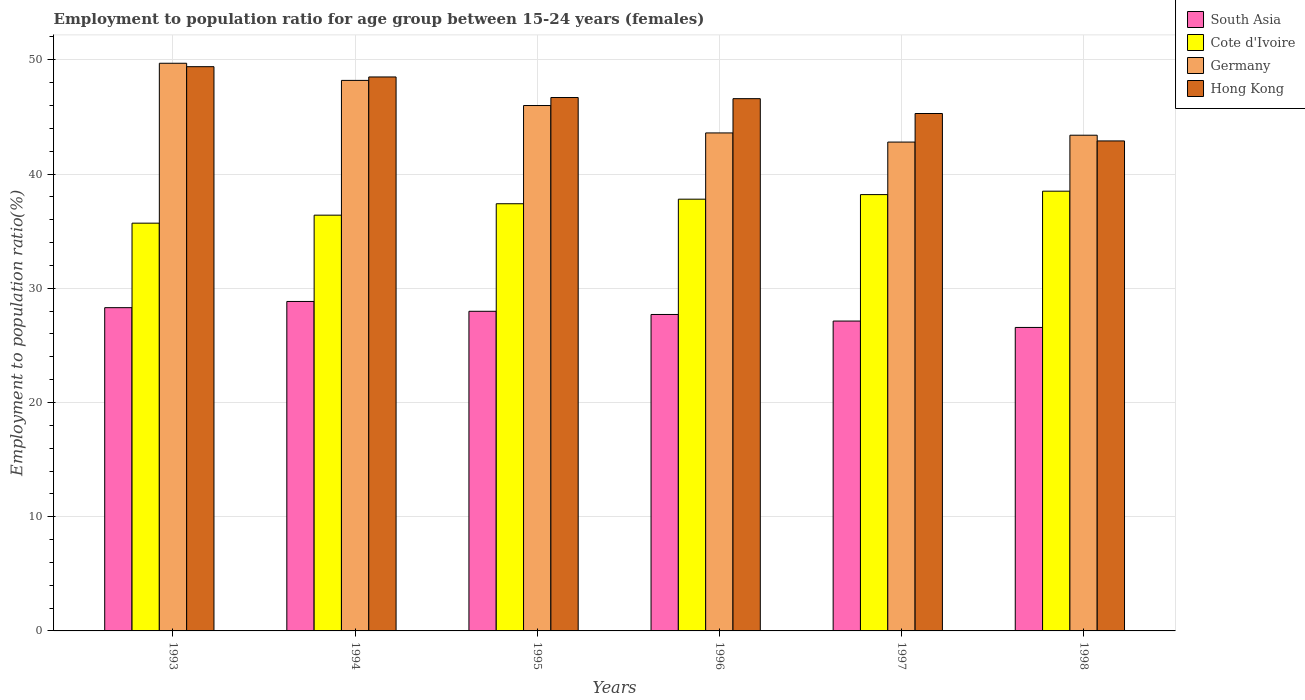Are the number of bars per tick equal to the number of legend labels?
Offer a very short reply. Yes. Are the number of bars on each tick of the X-axis equal?
Make the answer very short. Yes. How many bars are there on the 3rd tick from the left?
Ensure brevity in your answer.  4. How many bars are there on the 5th tick from the right?
Keep it short and to the point. 4. What is the employment to population ratio in Hong Kong in 1993?
Your answer should be very brief. 49.4. Across all years, what is the maximum employment to population ratio in South Asia?
Give a very brief answer. 28.85. Across all years, what is the minimum employment to population ratio in Germany?
Your answer should be compact. 42.8. In which year was the employment to population ratio in South Asia minimum?
Offer a very short reply. 1998. What is the total employment to population ratio in Cote d'Ivoire in the graph?
Offer a very short reply. 224. What is the difference between the employment to population ratio in Cote d'Ivoire in 1997 and the employment to population ratio in Hong Kong in 1998?
Make the answer very short. -4.7. What is the average employment to population ratio in Hong Kong per year?
Give a very brief answer. 46.57. In the year 1994, what is the difference between the employment to population ratio in Cote d'Ivoire and employment to population ratio in Germany?
Give a very brief answer. -11.8. In how many years, is the employment to population ratio in Hong Kong greater than 18 %?
Your answer should be very brief. 6. What is the ratio of the employment to population ratio in South Asia in 1993 to that in 1998?
Offer a very short reply. 1.07. What is the difference between the highest and the second highest employment to population ratio in Hong Kong?
Provide a short and direct response. 0.9. What is the difference between the highest and the lowest employment to population ratio in South Asia?
Keep it short and to the point. 2.27. What does the 2nd bar from the left in 1994 represents?
Keep it short and to the point. Cote d'Ivoire. Is it the case that in every year, the sum of the employment to population ratio in Hong Kong and employment to population ratio in Germany is greater than the employment to population ratio in Cote d'Ivoire?
Offer a terse response. Yes. How many bars are there?
Your response must be concise. 24. Are all the bars in the graph horizontal?
Provide a succinct answer. No. What is the difference between two consecutive major ticks on the Y-axis?
Your answer should be very brief. 10. Are the values on the major ticks of Y-axis written in scientific E-notation?
Provide a short and direct response. No. Does the graph contain grids?
Your answer should be compact. Yes. What is the title of the graph?
Provide a succinct answer. Employment to population ratio for age group between 15-24 years (females). Does "Tajikistan" appear as one of the legend labels in the graph?
Provide a succinct answer. No. What is the label or title of the X-axis?
Your answer should be compact. Years. What is the label or title of the Y-axis?
Give a very brief answer. Employment to population ratio(%). What is the Employment to population ratio(%) of South Asia in 1993?
Your answer should be compact. 28.3. What is the Employment to population ratio(%) in Cote d'Ivoire in 1993?
Provide a succinct answer. 35.7. What is the Employment to population ratio(%) of Germany in 1993?
Ensure brevity in your answer.  49.7. What is the Employment to population ratio(%) of Hong Kong in 1993?
Your response must be concise. 49.4. What is the Employment to population ratio(%) of South Asia in 1994?
Your response must be concise. 28.85. What is the Employment to population ratio(%) of Cote d'Ivoire in 1994?
Provide a succinct answer. 36.4. What is the Employment to population ratio(%) in Germany in 1994?
Keep it short and to the point. 48.2. What is the Employment to population ratio(%) in Hong Kong in 1994?
Provide a short and direct response. 48.5. What is the Employment to population ratio(%) of South Asia in 1995?
Keep it short and to the point. 27.98. What is the Employment to population ratio(%) in Cote d'Ivoire in 1995?
Your answer should be compact. 37.4. What is the Employment to population ratio(%) in Hong Kong in 1995?
Ensure brevity in your answer.  46.7. What is the Employment to population ratio(%) of South Asia in 1996?
Give a very brief answer. 27.7. What is the Employment to population ratio(%) of Cote d'Ivoire in 1996?
Provide a succinct answer. 37.8. What is the Employment to population ratio(%) in Germany in 1996?
Give a very brief answer. 43.6. What is the Employment to population ratio(%) of Hong Kong in 1996?
Your answer should be compact. 46.6. What is the Employment to population ratio(%) of South Asia in 1997?
Ensure brevity in your answer.  27.13. What is the Employment to population ratio(%) of Cote d'Ivoire in 1997?
Make the answer very short. 38.2. What is the Employment to population ratio(%) of Germany in 1997?
Provide a short and direct response. 42.8. What is the Employment to population ratio(%) in Hong Kong in 1997?
Ensure brevity in your answer.  45.3. What is the Employment to population ratio(%) in South Asia in 1998?
Keep it short and to the point. 26.57. What is the Employment to population ratio(%) in Cote d'Ivoire in 1998?
Offer a very short reply. 38.5. What is the Employment to population ratio(%) in Germany in 1998?
Provide a short and direct response. 43.4. What is the Employment to population ratio(%) in Hong Kong in 1998?
Your answer should be very brief. 42.9. Across all years, what is the maximum Employment to population ratio(%) in South Asia?
Offer a very short reply. 28.85. Across all years, what is the maximum Employment to population ratio(%) in Cote d'Ivoire?
Provide a short and direct response. 38.5. Across all years, what is the maximum Employment to population ratio(%) of Germany?
Your response must be concise. 49.7. Across all years, what is the maximum Employment to population ratio(%) of Hong Kong?
Provide a short and direct response. 49.4. Across all years, what is the minimum Employment to population ratio(%) of South Asia?
Offer a very short reply. 26.57. Across all years, what is the minimum Employment to population ratio(%) of Cote d'Ivoire?
Provide a short and direct response. 35.7. Across all years, what is the minimum Employment to population ratio(%) of Germany?
Provide a succinct answer. 42.8. Across all years, what is the minimum Employment to population ratio(%) in Hong Kong?
Your answer should be very brief. 42.9. What is the total Employment to population ratio(%) in South Asia in the graph?
Offer a terse response. 166.54. What is the total Employment to population ratio(%) in Cote d'Ivoire in the graph?
Your response must be concise. 224. What is the total Employment to population ratio(%) in Germany in the graph?
Your answer should be very brief. 273.7. What is the total Employment to population ratio(%) of Hong Kong in the graph?
Your response must be concise. 279.4. What is the difference between the Employment to population ratio(%) in South Asia in 1993 and that in 1994?
Provide a short and direct response. -0.54. What is the difference between the Employment to population ratio(%) of Cote d'Ivoire in 1993 and that in 1994?
Your answer should be very brief. -0.7. What is the difference between the Employment to population ratio(%) of Germany in 1993 and that in 1994?
Provide a short and direct response. 1.5. What is the difference between the Employment to population ratio(%) of Hong Kong in 1993 and that in 1994?
Provide a succinct answer. 0.9. What is the difference between the Employment to population ratio(%) of South Asia in 1993 and that in 1995?
Your answer should be very brief. 0.32. What is the difference between the Employment to population ratio(%) of Cote d'Ivoire in 1993 and that in 1995?
Your answer should be compact. -1.7. What is the difference between the Employment to population ratio(%) of Germany in 1993 and that in 1995?
Your answer should be very brief. 3.7. What is the difference between the Employment to population ratio(%) in Hong Kong in 1993 and that in 1995?
Your response must be concise. 2.7. What is the difference between the Employment to population ratio(%) in South Asia in 1993 and that in 1996?
Offer a very short reply. 0.6. What is the difference between the Employment to population ratio(%) of Cote d'Ivoire in 1993 and that in 1996?
Your answer should be compact. -2.1. What is the difference between the Employment to population ratio(%) in Germany in 1993 and that in 1996?
Your answer should be very brief. 6.1. What is the difference between the Employment to population ratio(%) in South Asia in 1993 and that in 1997?
Your response must be concise. 1.17. What is the difference between the Employment to population ratio(%) in Hong Kong in 1993 and that in 1997?
Provide a succinct answer. 4.1. What is the difference between the Employment to population ratio(%) in South Asia in 1993 and that in 1998?
Keep it short and to the point. 1.73. What is the difference between the Employment to population ratio(%) of Hong Kong in 1993 and that in 1998?
Offer a very short reply. 6.5. What is the difference between the Employment to population ratio(%) in South Asia in 1994 and that in 1995?
Offer a very short reply. 0.86. What is the difference between the Employment to population ratio(%) of South Asia in 1994 and that in 1996?
Give a very brief answer. 1.14. What is the difference between the Employment to population ratio(%) of Cote d'Ivoire in 1994 and that in 1996?
Offer a very short reply. -1.4. What is the difference between the Employment to population ratio(%) of Hong Kong in 1994 and that in 1996?
Provide a short and direct response. 1.9. What is the difference between the Employment to population ratio(%) of South Asia in 1994 and that in 1997?
Give a very brief answer. 1.72. What is the difference between the Employment to population ratio(%) of Germany in 1994 and that in 1997?
Keep it short and to the point. 5.4. What is the difference between the Employment to population ratio(%) of South Asia in 1994 and that in 1998?
Provide a short and direct response. 2.27. What is the difference between the Employment to population ratio(%) in Cote d'Ivoire in 1994 and that in 1998?
Make the answer very short. -2.1. What is the difference between the Employment to population ratio(%) of Hong Kong in 1994 and that in 1998?
Offer a terse response. 5.6. What is the difference between the Employment to population ratio(%) of South Asia in 1995 and that in 1996?
Offer a terse response. 0.28. What is the difference between the Employment to population ratio(%) of Cote d'Ivoire in 1995 and that in 1996?
Offer a very short reply. -0.4. What is the difference between the Employment to population ratio(%) in South Asia in 1995 and that in 1997?
Keep it short and to the point. 0.86. What is the difference between the Employment to population ratio(%) of Cote d'Ivoire in 1995 and that in 1997?
Make the answer very short. -0.8. What is the difference between the Employment to population ratio(%) of South Asia in 1995 and that in 1998?
Make the answer very short. 1.41. What is the difference between the Employment to population ratio(%) of Cote d'Ivoire in 1995 and that in 1998?
Offer a very short reply. -1.1. What is the difference between the Employment to population ratio(%) in South Asia in 1996 and that in 1997?
Give a very brief answer. 0.58. What is the difference between the Employment to population ratio(%) of Cote d'Ivoire in 1996 and that in 1997?
Give a very brief answer. -0.4. What is the difference between the Employment to population ratio(%) in Hong Kong in 1996 and that in 1997?
Give a very brief answer. 1.3. What is the difference between the Employment to population ratio(%) of South Asia in 1996 and that in 1998?
Your answer should be very brief. 1.13. What is the difference between the Employment to population ratio(%) of Cote d'Ivoire in 1996 and that in 1998?
Your answer should be compact. -0.7. What is the difference between the Employment to population ratio(%) of Hong Kong in 1996 and that in 1998?
Your answer should be very brief. 3.7. What is the difference between the Employment to population ratio(%) in South Asia in 1997 and that in 1998?
Offer a terse response. 0.56. What is the difference between the Employment to population ratio(%) of South Asia in 1993 and the Employment to population ratio(%) of Cote d'Ivoire in 1994?
Give a very brief answer. -8.1. What is the difference between the Employment to population ratio(%) in South Asia in 1993 and the Employment to population ratio(%) in Germany in 1994?
Ensure brevity in your answer.  -19.9. What is the difference between the Employment to population ratio(%) of South Asia in 1993 and the Employment to population ratio(%) of Hong Kong in 1994?
Make the answer very short. -20.2. What is the difference between the Employment to population ratio(%) of Cote d'Ivoire in 1993 and the Employment to population ratio(%) of Germany in 1994?
Your response must be concise. -12.5. What is the difference between the Employment to population ratio(%) in Germany in 1993 and the Employment to population ratio(%) in Hong Kong in 1994?
Give a very brief answer. 1.2. What is the difference between the Employment to population ratio(%) of South Asia in 1993 and the Employment to population ratio(%) of Cote d'Ivoire in 1995?
Make the answer very short. -9.1. What is the difference between the Employment to population ratio(%) of South Asia in 1993 and the Employment to population ratio(%) of Germany in 1995?
Provide a short and direct response. -17.7. What is the difference between the Employment to population ratio(%) of South Asia in 1993 and the Employment to population ratio(%) of Hong Kong in 1995?
Provide a succinct answer. -18.4. What is the difference between the Employment to population ratio(%) of Cote d'Ivoire in 1993 and the Employment to population ratio(%) of Germany in 1995?
Your answer should be compact. -10.3. What is the difference between the Employment to population ratio(%) of Cote d'Ivoire in 1993 and the Employment to population ratio(%) of Hong Kong in 1995?
Make the answer very short. -11. What is the difference between the Employment to population ratio(%) of Germany in 1993 and the Employment to population ratio(%) of Hong Kong in 1995?
Your response must be concise. 3. What is the difference between the Employment to population ratio(%) in South Asia in 1993 and the Employment to population ratio(%) in Cote d'Ivoire in 1996?
Give a very brief answer. -9.5. What is the difference between the Employment to population ratio(%) of South Asia in 1993 and the Employment to population ratio(%) of Germany in 1996?
Your answer should be compact. -15.3. What is the difference between the Employment to population ratio(%) of South Asia in 1993 and the Employment to population ratio(%) of Hong Kong in 1996?
Provide a short and direct response. -18.3. What is the difference between the Employment to population ratio(%) of Cote d'Ivoire in 1993 and the Employment to population ratio(%) of Germany in 1996?
Offer a very short reply. -7.9. What is the difference between the Employment to population ratio(%) in Cote d'Ivoire in 1993 and the Employment to population ratio(%) in Hong Kong in 1996?
Provide a succinct answer. -10.9. What is the difference between the Employment to population ratio(%) of South Asia in 1993 and the Employment to population ratio(%) of Cote d'Ivoire in 1997?
Make the answer very short. -9.9. What is the difference between the Employment to population ratio(%) of South Asia in 1993 and the Employment to population ratio(%) of Germany in 1997?
Your answer should be compact. -14.5. What is the difference between the Employment to population ratio(%) of South Asia in 1993 and the Employment to population ratio(%) of Hong Kong in 1997?
Offer a very short reply. -17. What is the difference between the Employment to population ratio(%) of Cote d'Ivoire in 1993 and the Employment to population ratio(%) of Germany in 1997?
Make the answer very short. -7.1. What is the difference between the Employment to population ratio(%) in Germany in 1993 and the Employment to population ratio(%) in Hong Kong in 1997?
Your answer should be very brief. 4.4. What is the difference between the Employment to population ratio(%) of South Asia in 1993 and the Employment to population ratio(%) of Cote d'Ivoire in 1998?
Your response must be concise. -10.2. What is the difference between the Employment to population ratio(%) in South Asia in 1993 and the Employment to population ratio(%) in Germany in 1998?
Offer a very short reply. -15.1. What is the difference between the Employment to population ratio(%) of South Asia in 1993 and the Employment to population ratio(%) of Hong Kong in 1998?
Your answer should be very brief. -14.6. What is the difference between the Employment to population ratio(%) of Cote d'Ivoire in 1993 and the Employment to population ratio(%) of Hong Kong in 1998?
Offer a terse response. -7.2. What is the difference between the Employment to population ratio(%) in South Asia in 1994 and the Employment to population ratio(%) in Cote d'Ivoire in 1995?
Offer a terse response. -8.55. What is the difference between the Employment to population ratio(%) in South Asia in 1994 and the Employment to population ratio(%) in Germany in 1995?
Provide a short and direct response. -17.15. What is the difference between the Employment to population ratio(%) in South Asia in 1994 and the Employment to population ratio(%) in Hong Kong in 1995?
Make the answer very short. -17.85. What is the difference between the Employment to population ratio(%) in Germany in 1994 and the Employment to population ratio(%) in Hong Kong in 1995?
Your answer should be compact. 1.5. What is the difference between the Employment to population ratio(%) of South Asia in 1994 and the Employment to population ratio(%) of Cote d'Ivoire in 1996?
Give a very brief answer. -8.95. What is the difference between the Employment to population ratio(%) of South Asia in 1994 and the Employment to population ratio(%) of Germany in 1996?
Give a very brief answer. -14.75. What is the difference between the Employment to population ratio(%) of South Asia in 1994 and the Employment to population ratio(%) of Hong Kong in 1996?
Provide a succinct answer. -17.75. What is the difference between the Employment to population ratio(%) in South Asia in 1994 and the Employment to population ratio(%) in Cote d'Ivoire in 1997?
Provide a short and direct response. -9.35. What is the difference between the Employment to population ratio(%) in South Asia in 1994 and the Employment to population ratio(%) in Germany in 1997?
Offer a very short reply. -13.95. What is the difference between the Employment to population ratio(%) of South Asia in 1994 and the Employment to population ratio(%) of Hong Kong in 1997?
Your answer should be very brief. -16.45. What is the difference between the Employment to population ratio(%) of Cote d'Ivoire in 1994 and the Employment to population ratio(%) of Germany in 1997?
Give a very brief answer. -6.4. What is the difference between the Employment to population ratio(%) in Germany in 1994 and the Employment to population ratio(%) in Hong Kong in 1997?
Your response must be concise. 2.9. What is the difference between the Employment to population ratio(%) in South Asia in 1994 and the Employment to population ratio(%) in Cote d'Ivoire in 1998?
Ensure brevity in your answer.  -9.65. What is the difference between the Employment to population ratio(%) in South Asia in 1994 and the Employment to population ratio(%) in Germany in 1998?
Give a very brief answer. -14.55. What is the difference between the Employment to population ratio(%) of South Asia in 1994 and the Employment to population ratio(%) of Hong Kong in 1998?
Provide a short and direct response. -14.05. What is the difference between the Employment to population ratio(%) in Cote d'Ivoire in 1994 and the Employment to population ratio(%) in Germany in 1998?
Offer a very short reply. -7. What is the difference between the Employment to population ratio(%) of South Asia in 1995 and the Employment to population ratio(%) of Cote d'Ivoire in 1996?
Give a very brief answer. -9.82. What is the difference between the Employment to population ratio(%) of South Asia in 1995 and the Employment to population ratio(%) of Germany in 1996?
Your answer should be very brief. -15.62. What is the difference between the Employment to population ratio(%) of South Asia in 1995 and the Employment to population ratio(%) of Hong Kong in 1996?
Keep it short and to the point. -18.62. What is the difference between the Employment to population ratio(%) in South Asia in 1995 and the Employment to population ratio(%) in Cote d'Ivoire in 1997?
Provide a succinct answer. -10.22. What is the difference between the Employment to population ratio(%) of South Asia in 1995 and the Employment to population ratio(%) of Germany in 1997?
Your answer should be compact. -14.82. What is the difference between the Employment to population ratio(%) of South Asia in 1995 and the Employment to population ratio(%) of Hong Kong in 1997?
Offer a terse response. -17.32. What is the difference between the Employment to population ratio(%) in South Asia in 1995 and the Employment to population ratio(%) in Cote d'Ivoire in 1998?
Make the answer very short. -10.52. What is the difference between the Employment to population ratio(%) of South Asia in 1995 and the Employment to population ratio(%) of Germany in 1998?
Provide a succinct answer. -15.42. What is the difference between the Employment to population ratio(%) of South Asia in 1995 and the Employment to population ratio(%) of Hong Kong in 1998?
Give a very brief answer. -14.92. What is the difference between the Employment to population ratio(%) in Cote d'Ivoire in 1995 and the Employment to population ratio(%) in Germany in 1998?
Provide a short and direct response. -6. What is the difference between the Employment to population ratio(%) of South Asia in 1996 and the Employment to population ratio(%) of Cote d'Ivoire in 1997?
Make the answer very short. -10.5. What is the difference between the Employment to population ratio(%) in South Asia in 1996 and the Employment to population ratio(%) in Germany in 1997?
Your response must be concise. -15.1. What is the difference between the Employment to population ratio(%) in South Asia in 1996 and the Employment to population ratio(%) in Hong Kong in 1997?
Provide a short and direct response. -17.6. What is the difference between the Employment to population ratio(%) of South Asia in 1996 and the Employment to population ratio(%) of Cote d'Ivoire in 1998?
Keep it short and to the point. -10.8. What is the difference between the Employment to population ratio(%) of South Asia in 1996 and the Employment to population ratio(%) of Germany in 1998?
Your answer should be very brief. -15.7. What is the difference between the Employment to population ratio(%) in South Asia in 1996 and the Employment to population ratio(%) in Hong Kong in 1998?
Provide a short and direct response. -15.2. What is the difference between the Employment to population ratio(%) of Cote d'Ivoire in 1996 and the Employment to population ratio(%) of Hong Kong in 1998?
Provide a short and direct response. -5.1. What is the difference between the Employment to population ratio(%) of Germany in 1996 and the Employment to population ratio(%) of Hong Kong in 1998?
Offer a terse response. 0.7. What is the difference between the Employment to population ratio(%) in South Asia in 1997 and the Employment to population ratio(%) in Cote d'Ivoire in 1998?
Offer a very short reply. -11.37. What is the difference between the Employment to population ratio(%) of South Asia in 1997 and the Employment to population ratio(%) of Germany in 1998?
Provide a short and direct response. -16.27. What is the difference between the Employment to population ratio(%) of South Asia in 1997 and the Employment to population ratio(%) of Hong Kong in 1998?
Your answer should be very brief. -15.77. What is the average Employment to population ratio(%) in South Asia per year?
Offer a terse response. 27.76. What is the average Employment to population ratio(%) in Cote d'Ivoire per year?
Your answer should be compact. 37.33. What is the average Employment to population ratio(%) in Germany per year?
Your answer should be compact. 45.62. What is the average Employment to population ratio(%) in Hong Kong per year?
Your response must be concise. 46.57. In the year 1993, what is the difference between the Employment to population ratio(%) of South Asia and Employment to population ratio(%) of Cote d'Ivoire?
Provide a succinct answer. -7.4. In the year 1993, what is the difference between the Employment to population ratio(%) of South Asia and Employment to population ratio(%) of Germany?
Offer a terse response. -21.4. In the year 1993, what is the difference between the Employment to population ratio(%) in South Asia and Employment to population ratio(%) in Hong Kong?
Offer a terse response. -21.1. In the year 1993, what is the difference between the Employment to population ratio(%) in Cote d'Ivoire and Employment to population ratio(%) in Germany?
Make the answer very short. -14. In the year 1993, what is the difference between the Employment to population ratio(%) in Cote d'Ivoire and Employment to population ratio(%) in Hong Kong?
Offer a very short reply. -13.7. In the year 1993, what is the difference between the Employment to population ratio(%) in Germany and Employment to population ratio(%) in Hong Kong?
Ensure brevity in your answer.  0.3. In the year 1994, what is the difference between the Employment to population ratio(%) in South Asia and Employment to population ratio(%) in Cote d'Ivoire?
Ensure brevity in your answer.  -7.55. In the year 1994, what is the difference between the Employment to population ratio(%) in South Asia and Employment to population ratio(%) in Germany?
Ensure brevity in your answer.  -19.35. In the year 1994, what is the difference between the Employment to population ratio(%) in South Asia and Employment to population ratio(%) in Hong Kong?
Make the answer very short. -19.65. In the year 1994, what is the difference between the Employment to population ratio(%) of Cote d'Ivoire and Employment to population ratio(%) of Hong Kong?
Offer a terse response. -12.1. In the year 1994, what is the difference between the Employment to population ratio(%) in Germany and Employment to population ratio(%) in Hong Kong?
Offer a terse response. -0.3. In the year 1995, what is the difference between the Employment to population ratio(%) in South Asia and Employment to population ratio(%) in Cote d'Ivoire?
Your answer should be compact. -9.42. In the year 1995, what is the difference between the Employment to population ratio(%) in South Asia and Employment to population ratio(%) in Germany?
Ensure brevity in your answer.  -18.02. In the year 1995, what is the difference between the Employment to population ratio(%) of South Asia and Employment to population ratio(%) of Hong Kong?
Offer a very short reply. -18.72. In the year 1995, what is the difference between the Employment to population ratio(%) of Cote d'Ivoire and Employment to population ratio(%) of Hong Kong?
Ensure brevity in your answer.  -9.3. In the year 1995, what is the difference between the Employment to population ratio(%) in Germany and Employment to population ratio(%) in Hong Kong?
Provide a short and direct response. -0.7. In the year 1996, what is the difference between the Employment to population ratio(%) in South Asia and Employment to population ratio(%) in Cote d'Ivoire?
Give a very brief answer. -10.1. In the year 1996, what is the difference between the Employment to population ratio(%) of South Asia and Employment to population ratio(%) of Germany?
Your response must be concise. -15.9. In the year 1996, what is the difference between the Employment to population ratio(%) in South Asia and Employment to population ratio(%) in Hong Kong?
Make the answer very short. -18.9. In the year 1996, what is the difference between the Employment to population ratio(%) of Cote d'Ivoire and Employment to population ratio(%) of Hong Kong?
Offer a terse response. -8.8. In the year 1997, what is the difference between the Employment to population ratio(%) of South Asia and Employment to population ratio(%) of Cote d'Ivoire?
Give a very brief answer. -11.07. In the year 1997, what is the difference between the Employment to population ratio(%) of South Asia and Employment to population ratio(%) of Germany?
Offer a very short reply. -15.67. In the year 1997, what is the difference between the Employment to population ratio(%) in South Asia and Employment to population ratio(%) in Hong Kong?
Your answer should be very brief. -18.17. In the year 1997, what is the difference between the Employment to population ratio(%) of Cote d'Ivoire and Employment to population ratio(%) of Germany?
Provide a short and direct response. -4.6. In the year 1997, what is the difference between the Employment to population ratio(%) of Cote d'Ivoire and Employment to population ratio(%) of Hong Kong?
Provide a succinct answer. -7.1. In the year 1998, what is the difference between the Employment to population ratio(%) of South Asia and Employment to population ratio(%) of Cote d'Ivoire?
Offer a terse response. -11.93. In the year 1998, what is the difference between the Employment to population ratio(%) in South Asia and Employment to population ratio(%) in Germany?
Provide a succinct answer. -16.83. In the year 1998, what is the difference between the Employment to population ratio(%) in South Asia and Employment to population ratio(%) in Hong Kong?
Provide a succinct answer. -16.33. In the year 1998, what is the difference between the Employment to population ratio(%) in Cote d'Ivoire and Employment to population ratio(%) in Hong Kong?
Your response must be concise. -4.4. What is the ratio of the Employment to population ratio(%) of South Asia in 1993 to that in 1994?
Provide a short and direct response. 0.98. What is the ratio of the Employment to population ratio(%) in Cote d'Ivoire in 1993 to that in 1994?
Your response must be concise. 0.98. What is the ratio of the Employment to population ratio(%) in Germany in 1993 to that in 1994?
Your answer should be compact. 1.03. What is the ratio of the Employment to population ratio(%) in Hong Kong in 1993 to that in 1994?
Your response must be concise. 1.02. What is the ratio of the Employment to population ratio(%) of South Asia in 1993 to that in 1995?
Make the answer very short. 1.01. What is the ratio of the Employment to population ratio(%) in Cote d'Ivoire in 1993 to that in 1995?
Give a very brief answer. 0.95. What is the ratio of the Employment to population ratio(%) of Germany in 1993 to that in 1995?
Give a very brief answer. 1.08. What is the ratio of the Employment to population ratio(%) of Hong Kong in 1993 to that in 1995?
Offer a very short reply. 1.06. What is the ratio of the Employment to population ratio(%) in South Asia in 1993 to that in 1996?
Offer a terse response. 1.02. What is the ratio of the Employment to population ratio(%) of Germany in 1993 to that in 1996?
Ensure brevity in your answer.  1.14. What is the ratio of the Employment to population ratio(%) in Hong Kong in 1993 to that in 1996?
Offer a very short reply. 1.06. What is the ratio of the Employment to population ratio(%) of South Asia in 1993 to that in 1997?
Keep it short and to the point. 1.04. What is the ratio of the Employment to population ratio(%) of Cote d'Ivoire in 1993 to that in 1997?
Make the answer very short. 0.93. What is the ratio of the Employment to population ratio(%) of Germany in 1993 to that in 1997?
Provide a short and direct response. 1.16. What is the ratio of the Employment to population ratio(%) of Hong Kong in 1993 to that in 1997?
Give a very brief answer. 1.09. What is the ratio of the Employment to population ratio(%) in South Asia in 1993 to that in 1998?
Ensure brevity in your answer.  1.07. What is the ratio of the Employment to population ratio(%) of Cote d'Ivoire in 1993 to that in 1998?
Your answer should be compact. 0.93. What is the ratio of the Employment to population ratio(%) in Germany in 1993 to that in 1998?
Ensure brevity in your answer.  1.15. What is the ratio of the Employment to population ratio(%) in Hong Kong in 1993 to that in 1998?
Provide a succinct answer. 1.15. What is the ratio of the Employment to population ratio(%) of South Asia in 1994 to that in 1995?
Give a very brief answer. 1.03. What is the ratio of the Employment to population ratio(%) in Cote d'Ivoire in 1994 to that in 1995?
Offer a very short reply. 0.97. What is the ratio of the Employment to population ratio(%) of Germany in 1994 to that in 1995?
Make the answer very short. 1.05. What is the ratio of the Employment to population ratio(%) of Hong Kong in 1994 to that in 1995?
Your response must be concise. 1.04. What is the ratio of the Employment to population ratio(%) of South Asia in 1994 to that in 1996?
Your response must be concise. 1.04. What is the ratio of the Employment to population ratio(%) of Cote d'Ivoire in 1994 to that in 1996?
Provide a short and direct response. 0.96. What is the ratio of the Employment to population ratio(%) of Germany in 1994 to that in 1996?
Provide a short and direct response. 1.11. What is the ratio of the Employment to population ratio(%) in Hong Kong in 1994 to that in 1996?
Keep it short and to the point. 1.04. What is the ratio of the Employment to population ratio(%) of South Asia in 1994 to that in 1997?
Keep it short and to the point. 1.06. What is the ratio of the Employment to population ratio(%) in Cote d'Ivoire in 1994 to that in 1997?
Offer a very short reply. 0.95. What is the ratio of the Employment to population ratio(%) of Germany in 1994 to that in 1997?
Your answer should be very brief. 1.13. What is the ratio of the Employment to population ratio(%) of Hong Kong in 1994 to that in 1997?
Offer a very short reply. 1.07. What is the ratio of the Employment to population ratio(%) in South Asia in 1994 to that in 1998?
Your answer should be very brief. 1.09. What is the ratio of the Employment to population ratio(%) in Cote d'Ivoire in 1994 to that in 1998?
Ensure brevity in your answer.  0.95. What is the ratio of the Employment to population ratio(%) in Germany in 1994 to that in 1998?
Provide a short and direct response. 1.11. What is the ratio of the Employment to population ratio(%) in Hong Kong in 1994 to that in 1998?
Keep it short and to the point. 1.13. What is the ratio of the Employment to population ratio(%) in Germany in 1995 to that in 1996?
Make the answer very short. 1.05. What is the ratio of the Employment to population ratio(%) in South Asia in 1995 to that in 1997?
Make the answer very short. 1.03. What is the ratio of the Employment to population ratio(%) in Cote d'Ivoire in 1995 to that in 1997?
Ensure brevity in your answer.  0.98. What is the ratio of the Employment to population ratio(%) in Germany in 1995 to that in 1997?
Your response must be concise. 1.07. What is the ratio of the Employment to population ratio(%) in Hong Kong in 1995 to that in 1997?
Offer a terse response. 1.03. What is the ratio of the Employment to population ratio(%) of South Asia in 1995 to that in 1998?
Offer a very short reply. 1.05. What is the ratio of the Employment to population ratio(%) of Cote d'Ivoire in 1995 to that in 1998?
Provide a succinct answer. 0.97. What is the ratio of the Employment to population ratio(%) in Germany in 1995 to that in 1998?
Your answer should be very brief. 1.06. What is the ratio of the Employment to population ratio(%) of Hong Kong in 1995 to that in 1998?
Keep it short and to the point. 1.09. What is the ratio of the Employment to population ratio(%) of South Asia in 1996 to that in 1997?
Provide a short and direct response. 1.02. What is the ratio of the Employment to population ratio(%) in Cote d'Ivoire in 1996 to that in 1997?
Provide a succinct answer. 0.99. What is the ratio of the Employment to population ratio(%) in Germany in 1996 to that in 1997?
Give a very brief answer. 1.02. What is the ratio of the Employment to population ratio(%) in Hong Kong in 1996 to that in 1997?
Give a very brief answer. 1.03. What is the ratio of the Employment to population ratio(%) of South Asia in 1996 to that in 1998?
Your answer should be very brief. 1.04. What is the ratio of the Employment to population ratio(%) in Cote d'Ivoire in 1996 to that in 1998?
Offer a very short reply. 0.98. What is the ratio of the Employment to population ratio(%) in Germany in 1996 to that in 1998?
Offer a terse response. 1. What is the ratio of the Employment to population ratio(%) in Hong Kong in 1996 to that in 1998?
Ensure brevity in your answer.  1.09. What is the ratio of the Employment to population ratio(%) in Germany in 1997 to that in 1998?
Make the answer very short. 0.99. What is the ratio of the Employment to population ratio(%) in Hong Kong in 1997 to that in 1998?
Your response must be concise. 1.06. What is the difference between the highest and the second highest Employment to population ratio(%) in South Asia?
Your response must be concise. 0.54. What is the difference between the highest and the second highest Employment to population ratio(%) in Cote d'Ivoire?
Keep it short and to the point. 0.3. What is the difference between the highest and the second highest Employment to population ratio(%) in Hong Kong?
Give a very brief answer. 0.9. What is the difference between the highest and the lowest Employment to population ratio(%) of South Asia?
Ensure brevity in your answer.  2.27. What is the difference between the highest and the lowest Employment to population ratio(%) in Germany?
Keep it short and to the point. 6.9. What is the difference between the highest and the lowest Employment to population ratio(%) in Hong Kong?
Your answer should be compact. 6.5. 